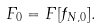Convert formula to latex. <formula><loc_0><loc_0><loc_500><loc_500>F _ { 0 } = F [ f _ { N , 0 } ] .</formula> 